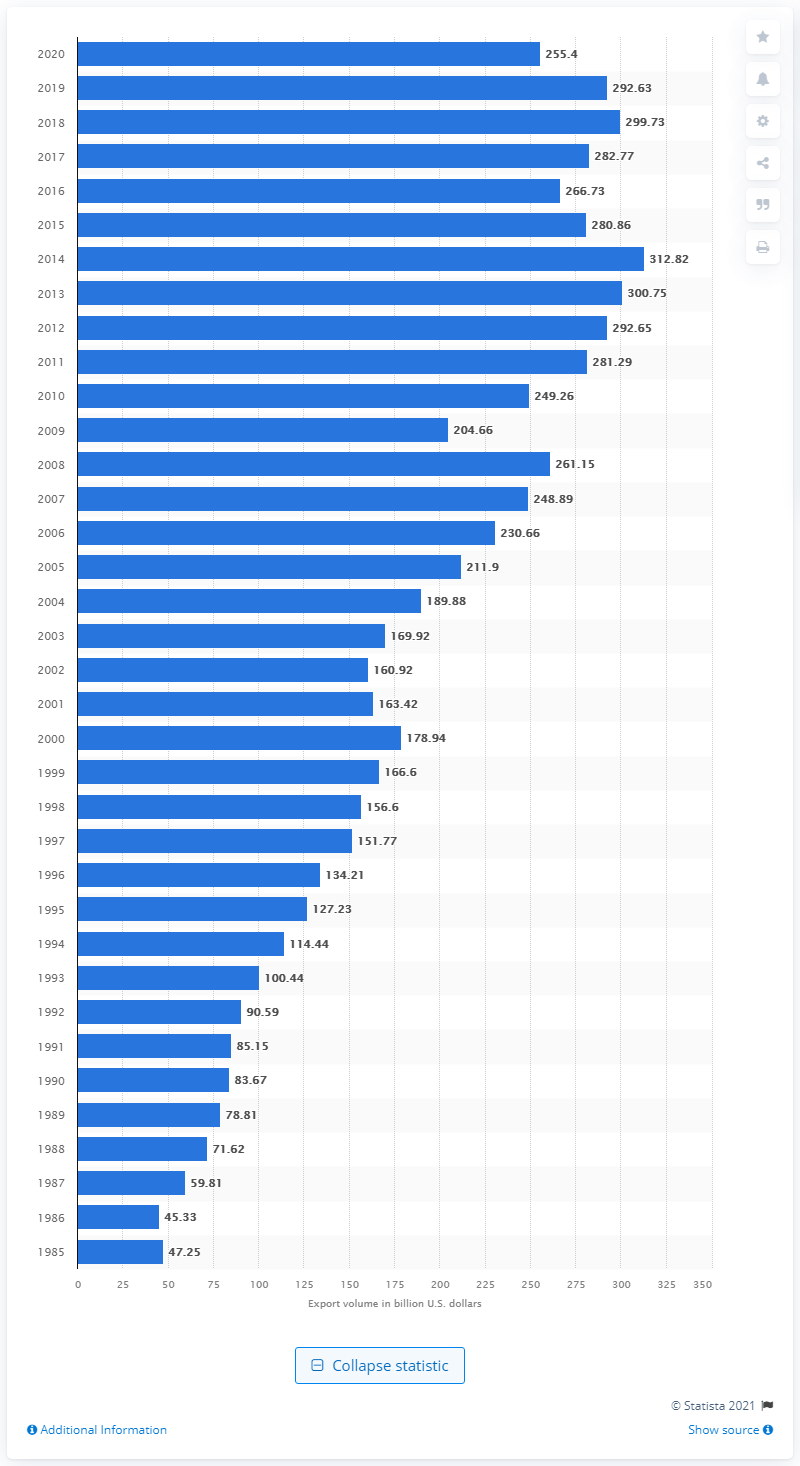Specify some key components in this picture. In 2020, the United States exported 255.4 million dollars worth of goods to Canada. 